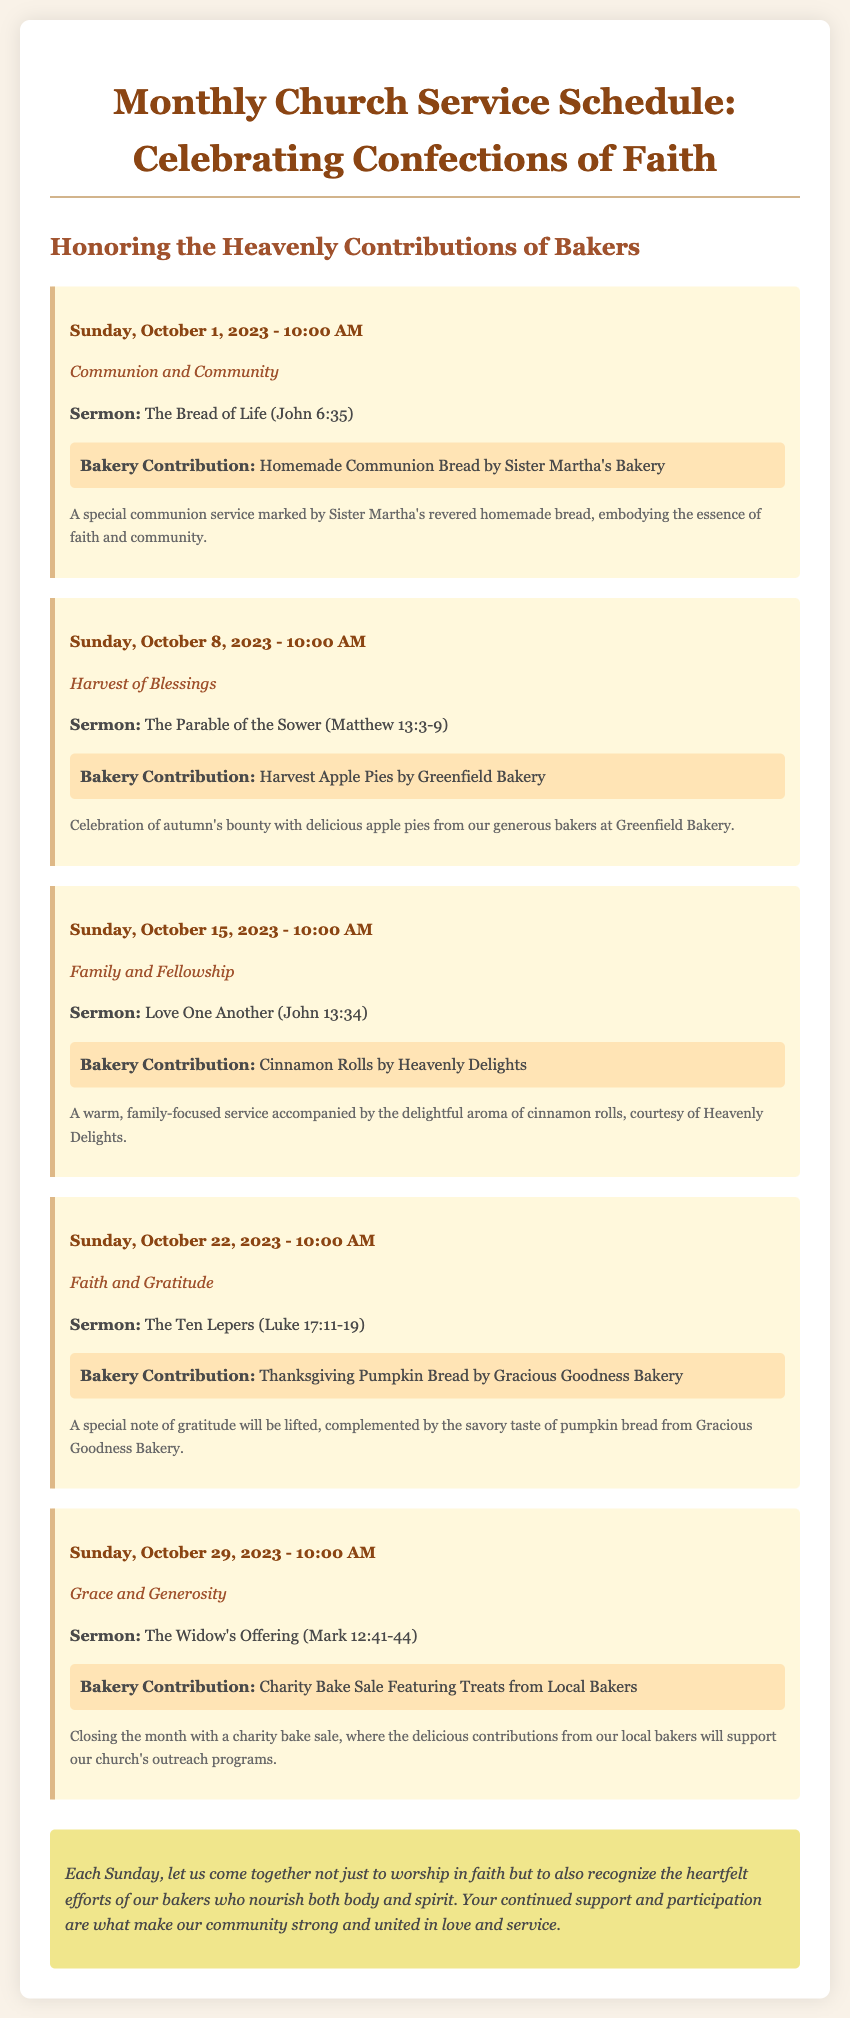What is the date of the first service? The first service is scheduled for Sunday, October 1, 2023.
Answer: October 1, 2023 What is the theme of the service on October 15? The theme of the service on October 15 is "Family and Fellowship."
Answer: Family and Fellowship Who contributed the homemade communion bread? Sister Martha's Bakery provided the homemade communion bread.
Answer: Sister Martha's Bakery What type of baked good is featured on October 22? The featured baked good for October 22 is Thanksgiving Pumpkin Bread.
Answer: Thanksgiving Pumpkin Bread What is the sermon topic for the service on October 29? The sermon topic for October 29 is "The Widow's Offering."
Answer: The Widow's Offering How many services are mentioned in the document? The document outlines five services in total.
Answer: Five What bakery contributed cinnamon rolls? Heavenly Delights contributed the cinnamon rolls for October 15.
Answer: Heavenly Delights What is the purpose of the charity bake sale on October 29? The charity bake sale is intended to support the church's outreach programs.
Answer: Support outreach programs What is the sermon reference for the first service? The sermon reference for the first service is John 6:35.
Answer: John 6:35 